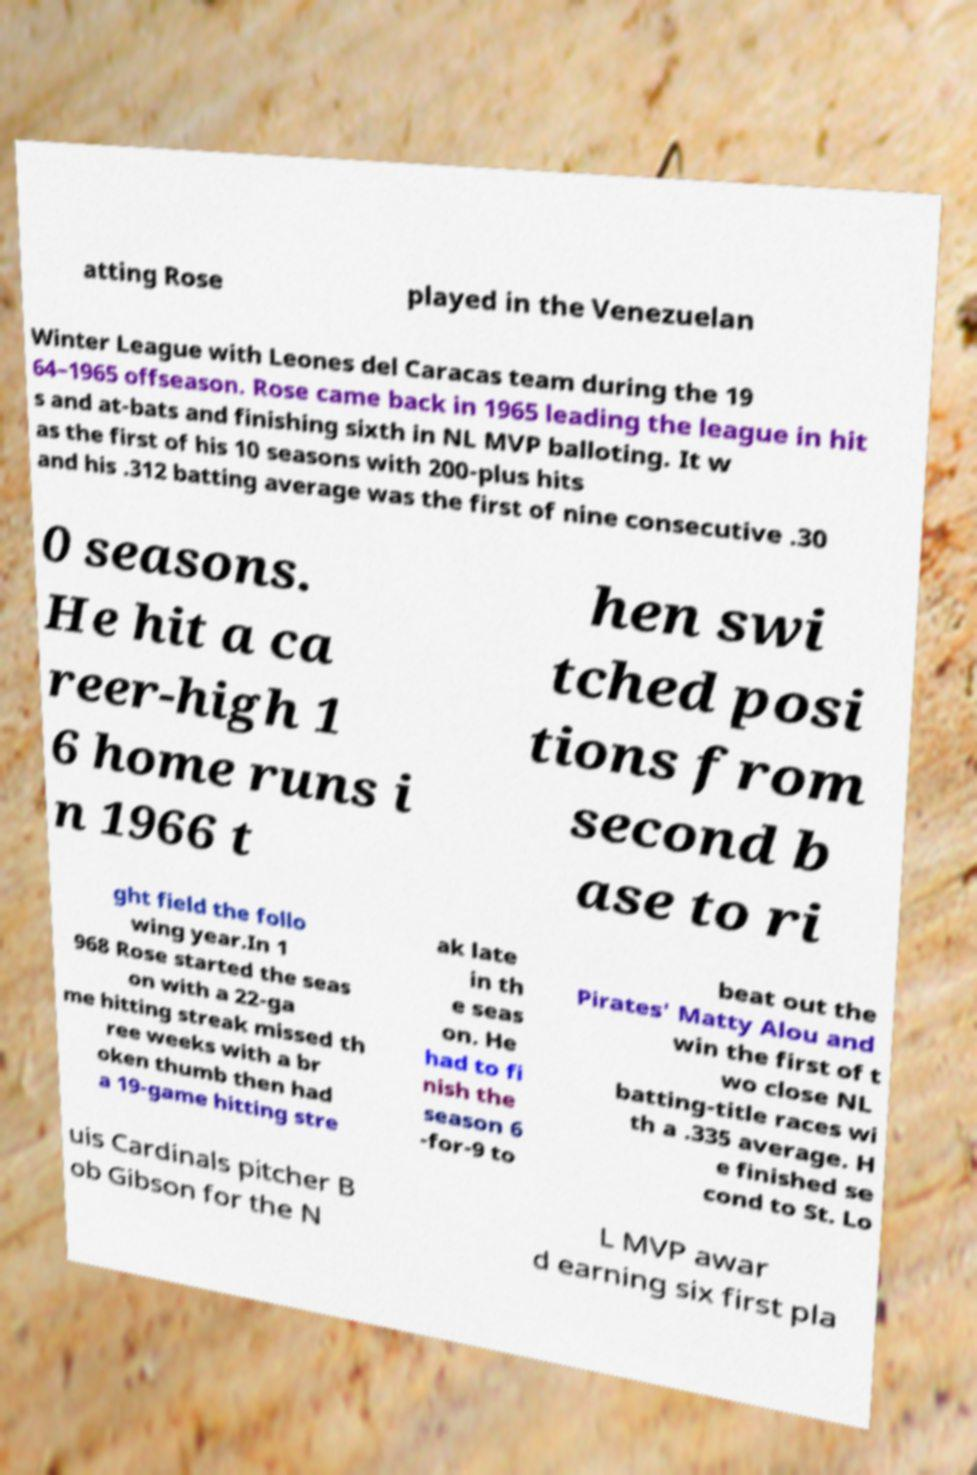Could you extract and type out the text from this image? atting Rose played in the Venezuelan Winter League with Leones del Caracas team during the 19 64–1965 offseason. Rose came back in 1965 leading the league in hit s and at-bats and finishing sixth in NL MVP balloting. It w as the first of his 10 seasons with 200-plus hits and his .312 batting average was the first of nine consecutive .30 0 seasons. He hit a ca reer-high 1 6 home runs i n 1966 t hen swi tched posi tions from second b ase to ri ght field the follo wing year.In 1 968 Rose started the seas on with a 22-ga me hitting streak missed th ree weeks with a br oken thumb then had a 19-game hitting stre ak late in th e seas on. He had to fi nish the season 6 -for-9 to beat out the Pirates' Matty Alou and win the first of t wo close NL batting-title races wi th a .335 average. H e finished se cond to St. Lo uis Cardinals pitcher B ob Gibson for the N L MVP awar d earning six first pla 